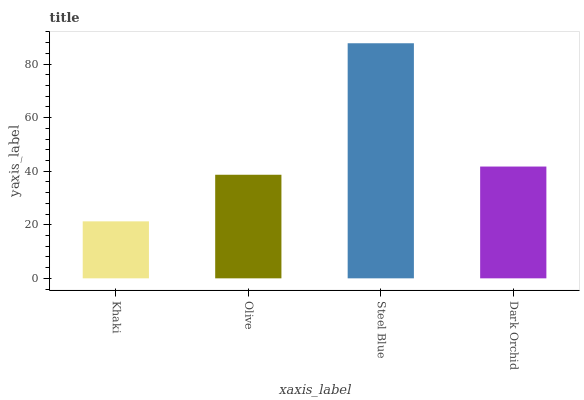Is Khaki the minimum?
Answer yes or no. Yes. Is Steel Blue the maximum?
Answer yes or no. Yes. Is Olive the minimum?
Answer yes or no. No. Is Olive the maximum?
Answer yes or no. No. Is Olive greater than Khaki?
Answer yes or no. Yes. Is Khaki less than Olive?
Answer yes or no. Yes. Is Khaki greater than Olive?
Answer yes or no. No. Is Olive less than Khaki?
Answer yes or no. No. Is Dark Orchid the high median?
Answer yes or no. Yes. Is Olive the low median?
Answer yes or no. Yes. Is Khaki the high median?
Answer yes or no. No. Is Khaki the low median?
Answer yes or no. No. 